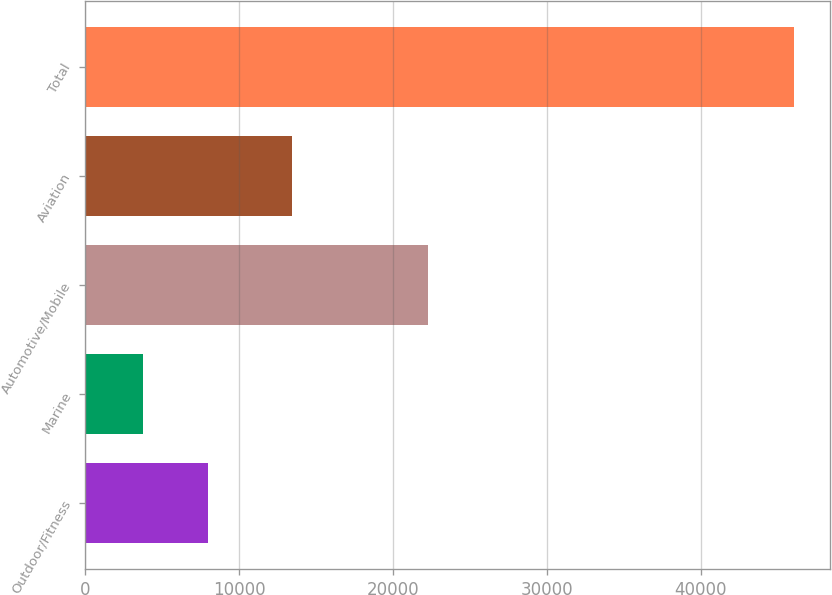Convert chart to OTSL. <chart><loc_0><loc_0><loc_500><loc_500><bar_chart><fcel>Outdoor/Fitness<fcel>Marine<fcel>Automotive/Mobile<fcel>Aviation<fcel>Total<nl><fcel>7991.4<fcel>3758<fcel>22265<fcel>13464<fcel>46092<nl></chart> 